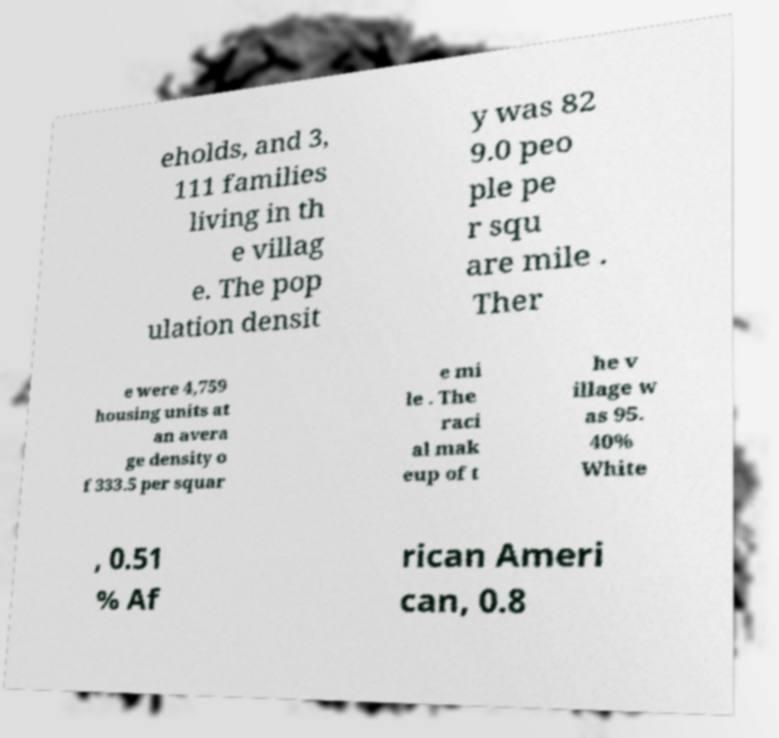Please identify and transcribe the text found in this image. eholds, and 3, 111 families living in th e villag e. The pop ulation densit y was 82 9.0 peo ple pe r squ are mile . Ther e were 4,759 housing units at an avera ge density o f 333.5 per squar e mi le . The raci al mak eup of t he v illage w as 95. 40% White , 0.51 % Af rican Ameri can, 0.8 